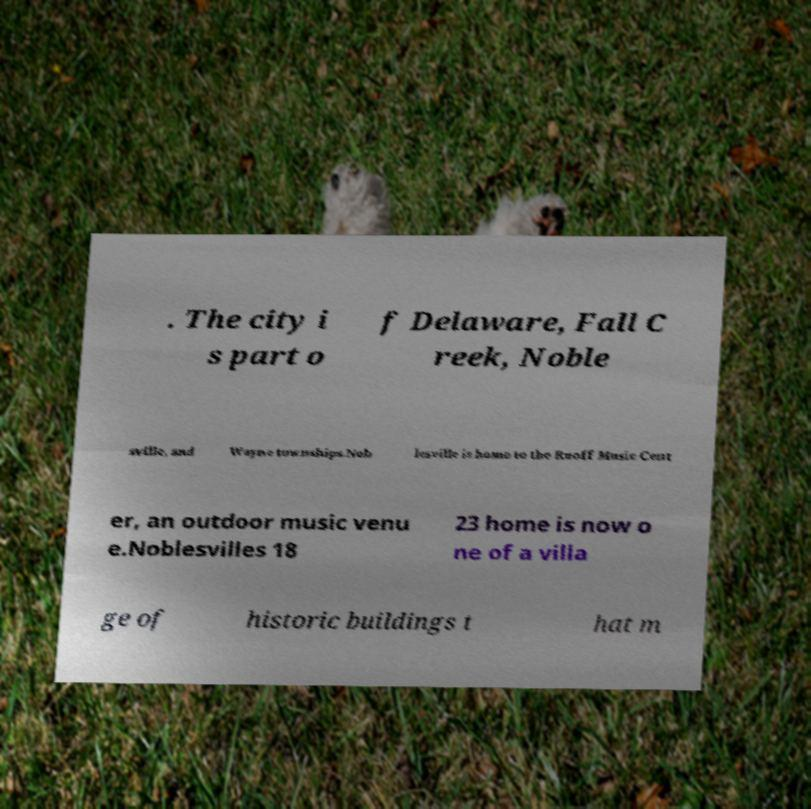Could you assist in decoding the text presented in this image and type it out clearly? . The city i s part o f Delaware, Fall C reek, Noble sville, and Wayne townships.Nob lesville is home to the Ruoff Music Cent er, an outdoor music venu e.Noblesvilles 18 23 home is now o ne of a villa ge of historic buildings t hat m 